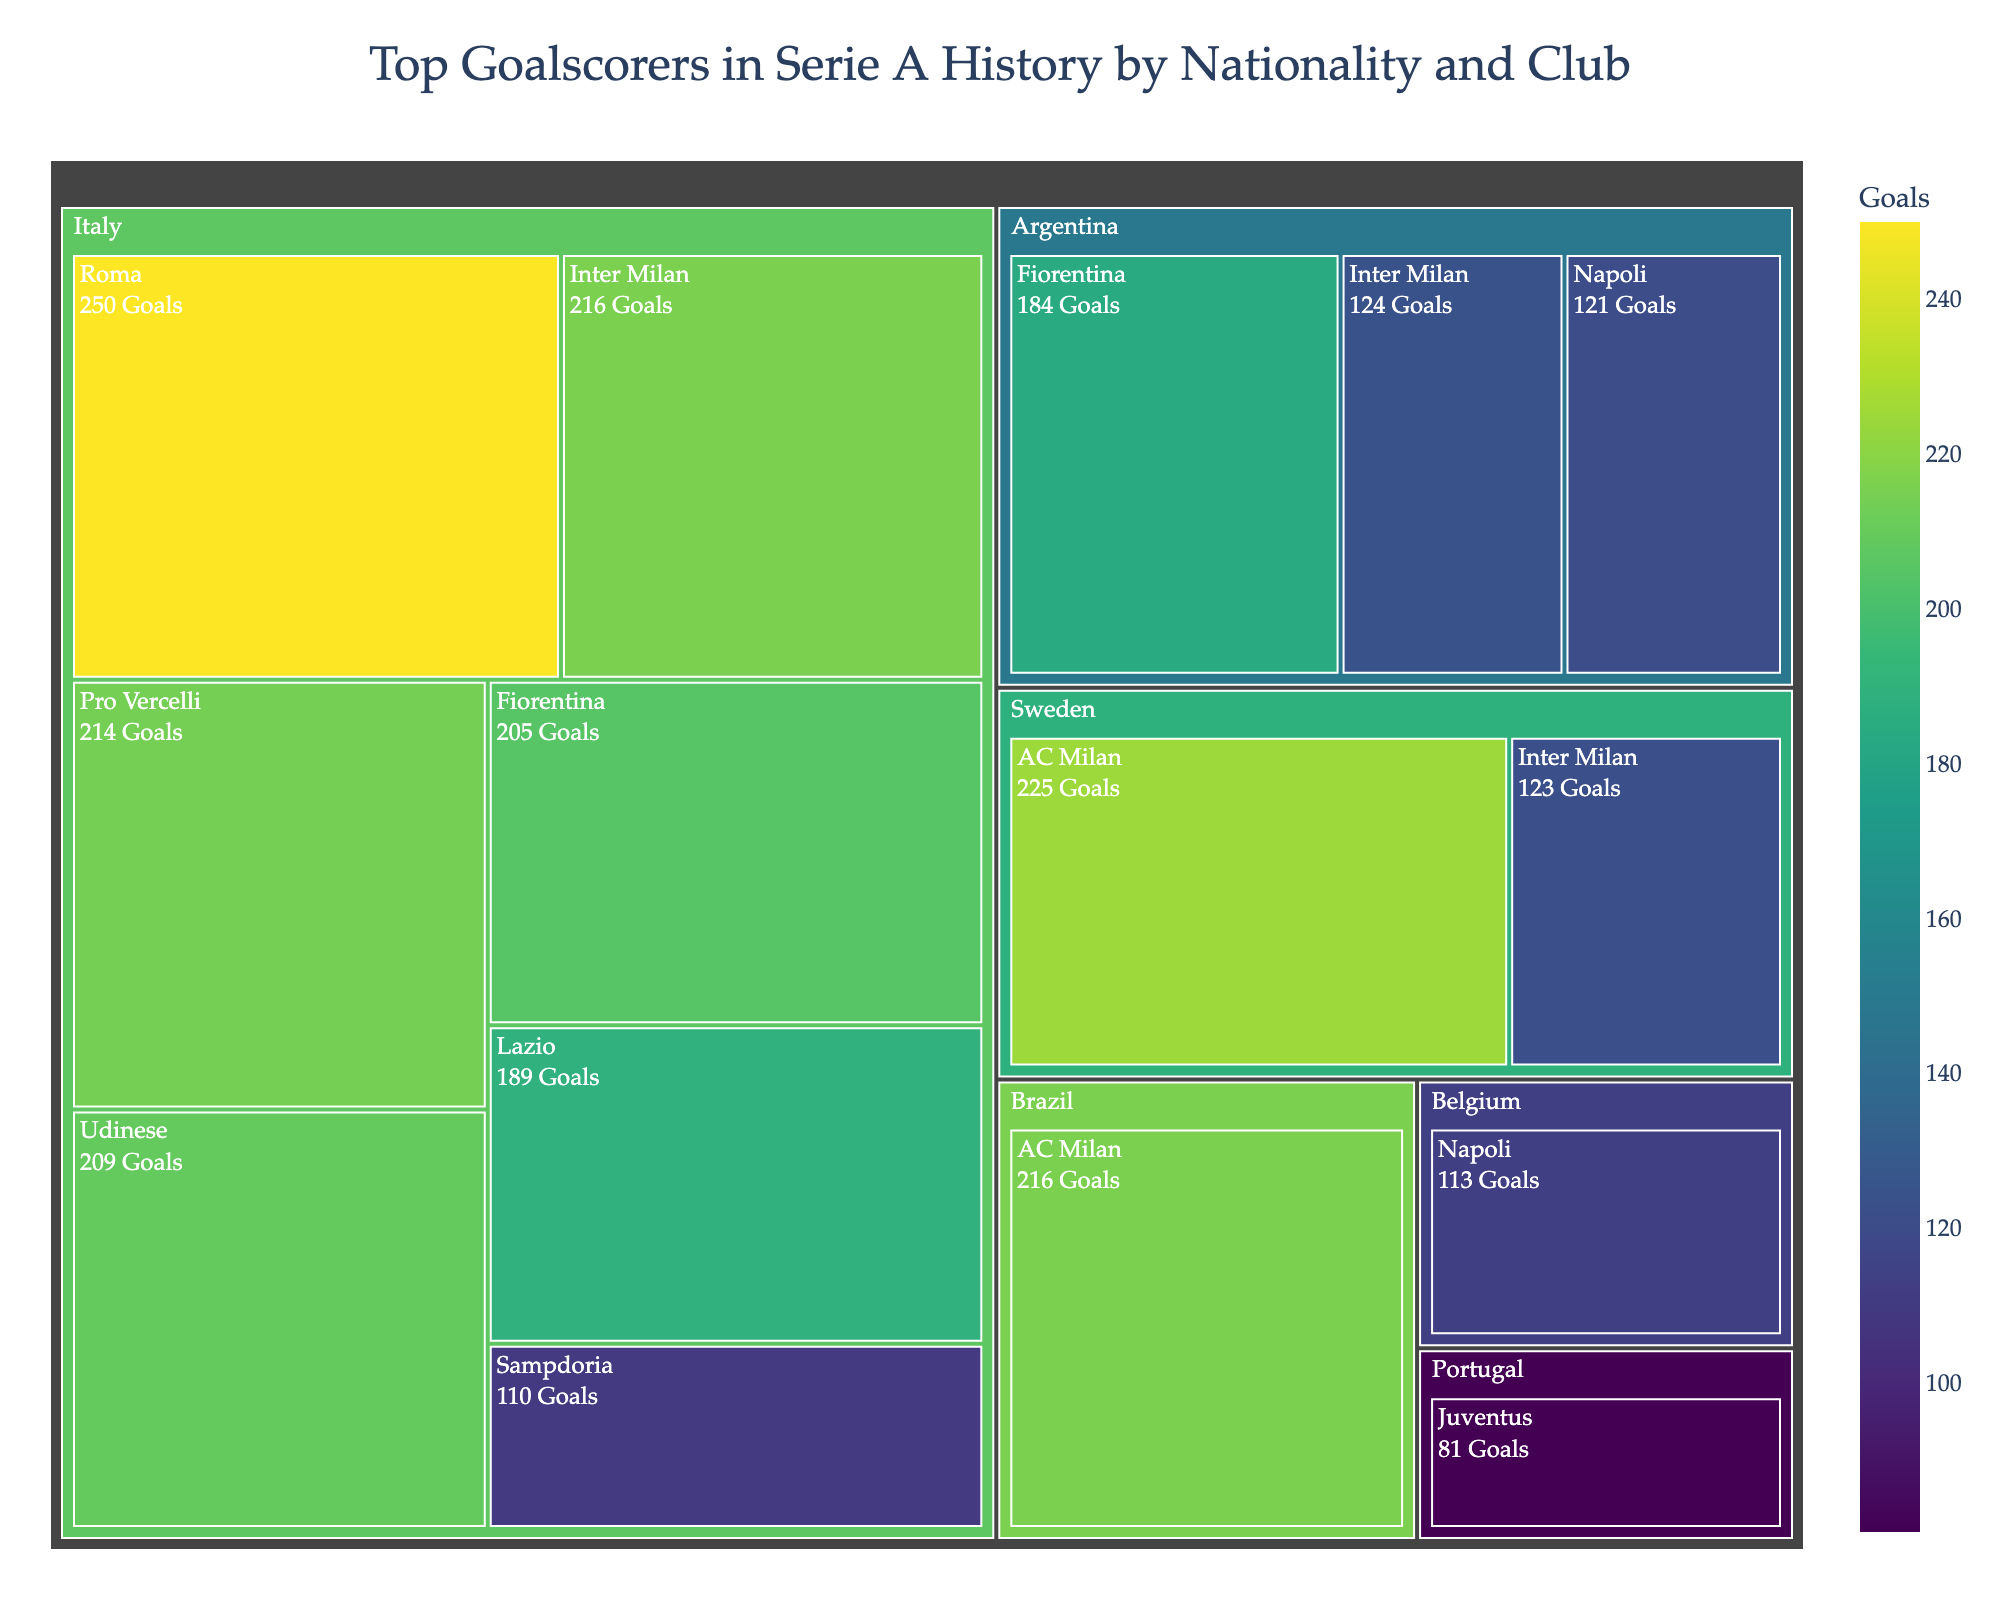What is the title of the figure? The title of the figure is displayed at the top and provides an overview of the subject represented in the treemap. In this case, the title is given as 'Top Goalscorers in Serie A History by Nationality and Club'.
Answer: 'Top Goalscorers in Serie A History by Nationality and Club' Which nationality has the highest number of goals in Serie A history? To determine the nationality with the highest number of goals, we observe the size of the rectangles in the treemap for each nationality. The largest rectangle represents the nationality with the most goals.
Answer: Italy Which club has the most goals scored by Argentinian players? Within the Argentinian nationality section, compare the sizes of the rectangles corresponding to each club. The largest rectangle will indicate the club with the most goals.
Answer: Fiorentina How many goals were scored by Swedish players in Serie A? Look for the section representing Swedish nationality and sum the number of goals from all clubs within this section. The values are indicated in the rectangles.
Answer: 348 Who are the top goalscorers from the Italian nationality? Refer to the Italian section and list the players represented, focusing on those with the highest number of goals.
Answer: Francesco Totti, Giuseppe Meazza, Silvio Piola, Roberto Baggio, Antonio Di Natale, Ciro Immobile, Giampaolo Pazzini What is the difference between the total goals scored by Brazilian and Portuguese players? Identify the rectangles for Brazilian and Portuguese players. For Brazilian players, the only scorer is José Altafini (216 goals). For Portuguese players, Ronaldo scored 81 goals. Calculate the difference: 216 - 81.
Answer: 135 Which club has the fewest goals from its top goalscorers in Serie A history? Compare the sizes of the rectangles representing each club under their respective nationalities. The smallest rectangle on aggregate represents the club with the fewest goals.
Answer: Juventus How many clubs have Italian top goalscorers? Within the Italian section, count the distinct clubs represented by the rectangles.
Answer: 6 Who is the top goalscorer from Sweden and which club did he play for? Look in the Swedish section of the treemap to identify the player with the most goals. The largest rectangle will be labeled with the name and associated club.
Answer: Gunnar Nordahl, AC Milan Which nationality has the most diversified club representation among top goalscorers? Check the number of distinct clubs under each nationality section. The nationality with rectangles corresponding to the highest number of different clubs is the most diversified.
Answer: Italy 